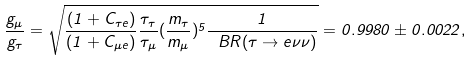Convert formula to latex. <formula><loc_0><loc_0><loc_500><loc_500>\frac { g _ { \mu } } { g _ { \tau } } = \sqrt { \frac { ( 1 + C _ { \tau e } ) } { ( 1 + C _ { \mu e } ) } \frac { \tau _ { \tau } } { \tau _ { \mu } } ( \frac { m _ { \tau } } { m _ { \mu } } ) ^ { 5 } \frac { 1 } { \ B R ( \tau \to e \nu \nu ) } } = 0 . 9 9 8 0 \pm 0 . 0 0 2 2 ,</formula> 